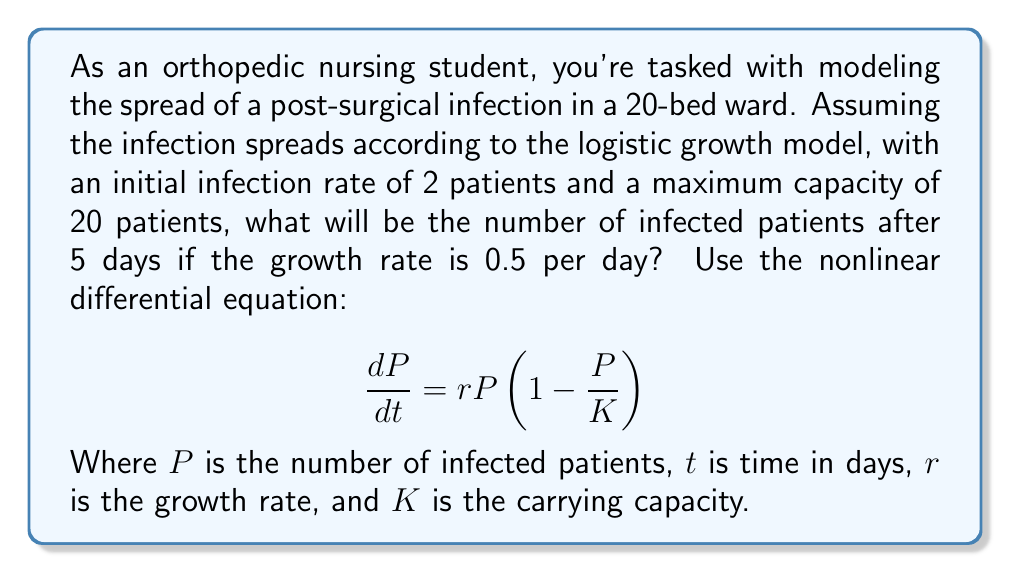Help me with this question. Let's approach this step-by-step:

1) We're given the logistic growth model:
   $$\frac{dP}{dt} = rP(1-\frac{P}{K})$$

2) We know:
   - Initial number of infected patients, $P_0 = 2$
   - Carrying capacity, $K = 20$
   - Growth rate, $r = 0.5$ per day
   - Time, $t = 5$ days

3) The solution to this differential equation is:
   $$P(t) = \frac{KP_0e^{rt}}{K + P_0(e^{rt} - 1)}$$

4) Let's substitute our values:
   $$P(5) = \frac{20 \cdot 2 \cdot e^{0.5 \cdot 5}}{20 + 2(e^{0.5 \cdot 5} - 1)}$$

5) Simplify the exponent:
   $$P(5) = \frac{40e^{2.5}}{20 + 2(e^{2.5} - 1)}$$

6) Calculate $e^{2.5}$ (approximately 12.1825):
   $$P(5) = \frac{40 \cdot 12.1825}{20 + 2(12.1825 - 1)}$$

7) Simplify:
   $$P(5) = \frac{487.3}{20 + 22.365} = \frac{487.3}{42.365}$$

8) Calculate the final result:
   $$P(5) \approx 11.5$$

9) Since we're dealing with whole patients, we round to the nearest integer:
   $$P(5) \approx 12$$
Answer: 12 patients 